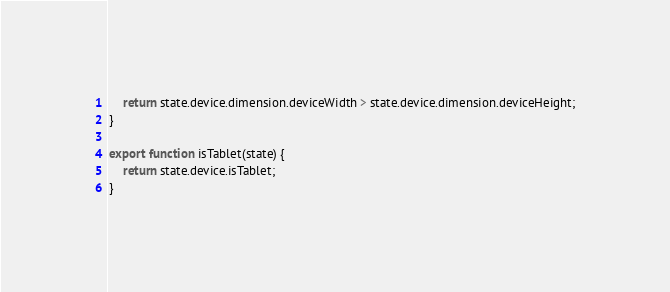Convert code to text. <code><loc_0><loc_0><loc_500><loc_500><_JavaScript_>    return state.device.dimension.deviceWidth > state.device.dimension.deviceHeight;
}

export function isTablet(state) {
    return state.device.isTablet;
}
</code> 